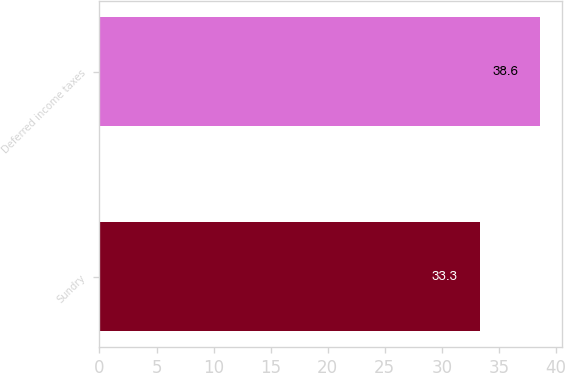Convert chart. <chart><loc_0><loc_0><loc_500><loc_500><bar_chart><fcel>Sundry<fcel>Deferred income taxes<nl><fcel>33.3<fcel>38.6<nl></chart> 